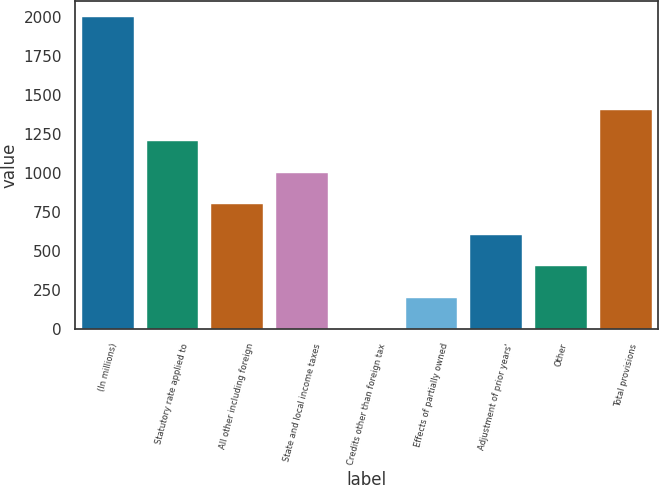Convert chart to OTSL. <chart><loc_0><loc_0><loc_500><loc_500><bar_chart><fcel>(In millions)<fcel>Statutory rate applied to<fcel>All other including foreign<fcel>State and local income taxes<fcel>Credits other than foreign tax<fcel>Effects of partially owned<fcel>Adjustment of prior years'<fcel>Other<fcel>Total provisions<nl><fcel>2004<fcel>1203.2<fcel>802.8<fcel>1003<fcel>2<fcel>202.2<fcel>602.6<fcel>402.4<fcel>1403.4<nl></chart> 